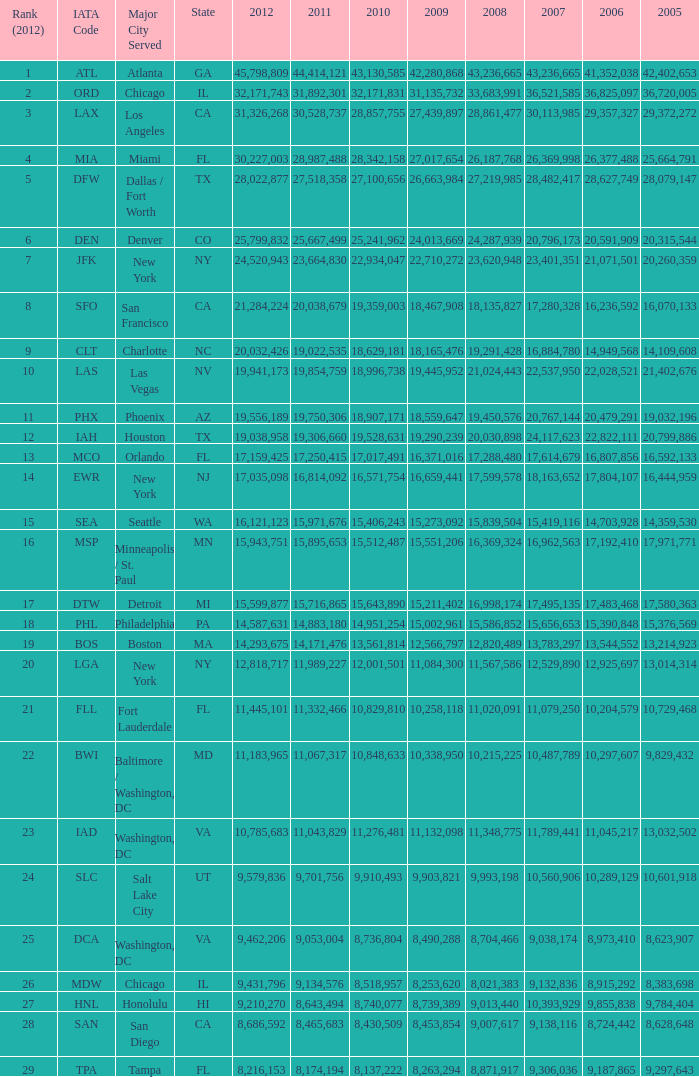What is the top 2010 for miami, fl? 28342158.0. 